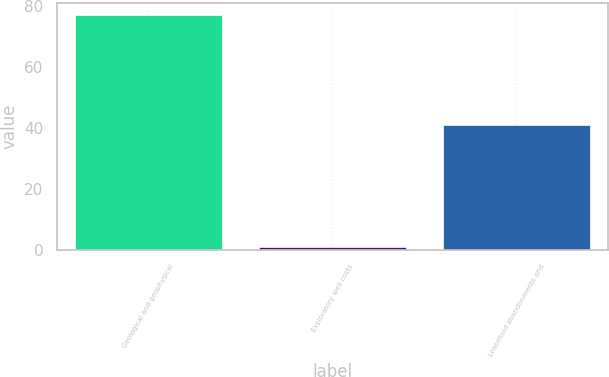Convert chart. <chart><loc_0><loc_0><loc_500><loc_500><bar_chart><fcel>Geological and geophysical<fcel>Exploratory well costs<fcel>Leasehold abandonments and<nl><fcel>77<fcel>1<fcel>41<nl></chart> 